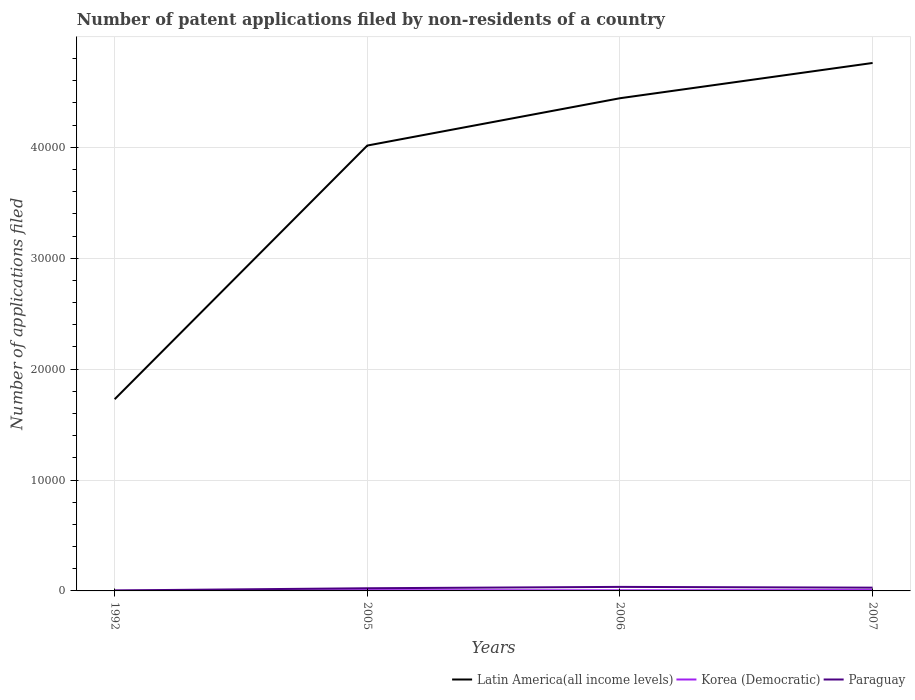Is the number of lines equal to the number of legend labels?
Your answer should be compact. Yes. Across all years, what is the maximum number of applications filed in Latin America(all income levels)?
Your answer should be very brief. 1.73e+04. What is the total number of applications filed in Latin America(all income levels) in the graph?
Give a very brief answer. -7447. What is the difference between the highest and the second highest number of applications filed in Latin America(all income levels)?
Ensure brevity in your answer.  3.03e+04. What is the difference between the highest and the lowest number of applications filed in Paraguay?
Offer a very short reply. 3. Does the graph contain any zero values?
Your answer should be compact. No. How are the legend labels stacked?
Make the answer very short. Horizontal. What is the title of the graph?
Give a very brief answer. Number of patent applications filed by non-residents of a country. Does "Fiji" appear as one of the legend labels in the graph?
Offer a very short reply. No. What is the label or title of the Y-axis?
Offer a terse response. Number of applications filed. What is the Number of applications filed in Latin America(all income levels) in 1992?
Keep it short and to the point. 1.73e+04. What is the Number of applications filed in Latin America(all income levels) in 2005?
Make the answer very short. 4.02e+04. What is the Number of applications filed in Korea (Democratic) in 2005?
Offer a terse response. 66. What is the Number of applications filed of Paraguay in 2005?
Your answer should be compact. 241. What is the Number of applications filed in Latin America(all income levels) in 2006?
Give a very brief answer. 4.44e+04. What is the Number of applications filed of Paraguay in 2006?
Your answer should be compact. 364. What is the Number of applications filed of Latin America(all income levels) in 2007?
Your response must be concise. 4.76e+04. What is the Number of applications filed of Paraguay in 2007?
Offer a terse response. 295. Across all years, what is the maximum Number of applications filed of Latin America(all income levels)?
Your answer should be compact. 4.76e+04. Across all years, what is the maximum Number of applications filed in Korea (Democratic)?
Your response must be concise. 76. Across all years, what is the maximum Number of applications filed of Paraguay?
Make the answer very short. 364. Across all years, what is the minimum Number of applications filed of Latin America(all income levels)?
Your answer should be very brief. 1.73e+04. Across all years, what is the minimum Number of applications filed in Korea (Democratic)?
Keep it short and to the point. 8. What is the total Number of applications filed in Latin America(all income levels) in the graph?
Your response must be concise. 1.49e+05. What is the total Number of applications filed in Korea (Democratic) in the graph?
Your answer should be compact. 206. What is the total Number of applications filed in Paraguay in the graph?
Provide a succinct answer. 944. What is the difference between the Number of applications filed in Latin America(all income levels) in 1992 and that in 2005?
Make the answer very short. -2.29e+04. What is the difference between the Number of applications filed of Korea (Democratic) in 1992 and that in 2005?
Ensure brevity in your answer.  -58. What is the difference between the Number of applications filed in Paraguay in 1992 and that in 2005?
Give a very brief answer. -197. What is the difference between the Number of applications filed of Latin America(all income levels) in 1992 and that in 2006?
Provide a short and direct response. -2.71e+04. What is the difference between the Number of applications filed in Korea (Democratic) in 1992 and that in 2006?
Ensure brevity in your answer.  -48. What is the difference between the Number of applications filed in Paraguay in 1992 and that in 2006?
Give a very brief answer. -320. What is the difference between the Number of applications filed in Latin America(all income levels) in 1992 and that in 2007?
Offer a terse response. -3.03e+04. What is the difference between the Number of applications filed in Korea (Democratic) in 1992 and that in 2007?
Your answer should be compact. -68. What is the difference between the Number of applications filed of Paraguay in 1992 and that in 2007?
Offer a terse response. -251. What is the difference between the Number of applications filed in Latin America(all income levels) in 2005 and that in 2006?
Your response must be concise. -4267. What is the difference between the Number of applications filed in Paraguay in 2005 and that in 2006?
Provide a short and direct response. -123. What is the difference between the Number of applications filed in Latin America(all income levels) in 2005 and that in 2007?
Provide a short and direct response. -7447. What is the difference between the Number of applications filed in Korea (Democratic) in 2005 and that in 2007?
Your response must be concise. -10. What is the difference between the Number of applications filed of Paraguay in 2005 and that in 2007?
Keep it short and to the point. -54. What is the difference between the Number of applications filed of Latin America(all income levels) in 2006 and that in 2007?
Your answer should be compact. -3180. What is the difference between the Number of applications filed in Korea (Democratic) in 2006 and that in 2007?
Offer a very short reply. -20. What is the difference between the Number of applications filed of Latin America(all income levels) in 1992 and the Number of applications filed of Korea (Democratic) in 2005?
Give a very brief answer. 1.72e+04. What is the difference between the Number of applications filed of Latin America(all income levels) in 1992 and the Number of applications filed of Paraguay in 2005?
Ensure brevity in your answer.  1.70e+04. What is the difference between the Number of applications filed of Korea (Democratic) in 1992 and the Number of applications filed of Paraguay in 2005?
Your answer should be compact. -233. What is the difference between the Number of applications filed in Latin America(all income levels) in 1992 and the Number of applications filed in Korea (Democratic) in 2006?
Make the answer very short. 1.72e+04. What is the difference between the Number of applications filed of Latin America(all income levels) in 1992 and the Number of applications filed of Paraguay in 2006?
Give a very brief answer. 1.69e+04. What is the difference between the Number of applications filed of Korea (Democratic) in 1992 and the Number of applications filed of Paraguay in 2006?
Ensure brevity in your answer.  -356. What is the difference between the Number of applications filed in Latin America(all income levels) in 1992 and the Number of applications filed in Korea (Democratic) in 2007?
Ensure brevity in your answer.  1.72e+04. What is the difference between the Number of applications filed in Latin America(all income levels) in 1992 and the Number of applications filed in Paraguay in 2007?
Provide a succinct answer. 1.70e+04. What is the difference between the Number of applications filed of Korea (Democratic) in 1992 and the Number of applications filed of Paraguay in 2007?
Give a very brief answer. -287. What is the difference between the Number of applications filed of Latin America(all income levels) in 2005 and the Number of applications filed of Korea (Democratic) in 2006?
Your answer should be compact. 4.01e+04. What is the difference between the Number of applications filed of Latin America(all income levels) in 2005 and the Number of applications filed of Paraguay in 2006?
Provide a succinct answer. 3.98e+04. What is the difference between the Number of applications filed of Korea (Democratic) in 2005 and the Number of applications filed of Paraguay in 2006?
Your answer should be very brief. -298. What is the difference between the Number of applications filed in Latin America(all income levels) in 2005 and the Number of applications filed in Korea (Democratic) in 2007?
Provide a short and direct response. 4.01e+04. What is the difference between the Number of applications filed of Latin America(all income levels) in 2005 and the Number of applications filed of Paraguay in 2007?
Your answer should be compact. 3.99e+04. What is the difference between the Number of applications filed of Korea (Democratic) in 2005 and the Number of applications filed of Paraguay in 2007?
Provide a short and direct response. -229. What is the difference between the Number of applications filed of Latin America(all income levels) in 2006 and the Number of applications filed of Korea (Democratic) in 2007?
Your answer should be very brief. 4.44e+04. What is the difference between the Number of applications filed of Latin America(all income levels) in 2006 and the Number of applications filed of Paraguay in 2007?
Keep it short and to the point. 4.41e+04. What is the difference between the Number of applications filed of Korea (Democratic) in 2006 and the Number of applications filed of Paraguay in 2007?
Offer a very short reply. -239. What is the average Number of applications filed in Latin America(all income levels) per year?
Provide a short and direct response. 3.74e+04. What is the average Number of applications filed of Korea (Democratic) per year?
Offer a very short reply. 51.5. What is the average Number of applications filed of Paraguay per year?
Provide a succinct answer. 236. In the year 1992, what is the difference between the Number of applications filed in Latin America(all income levels) and Number of applications filed in Korea (Democratic)?
Make the answer very short. 1.73e+04. In the year 1992, what is the difference between the Number of applications filed in Latin America(all income levels) and Number of applications filed in Paraguay?
Your answer should be very brief. 1.72e+04. In the year 1992, what is the difference between the Number of applications filed of Korea (Democratic) and Number of applications filed of Paraguay?
Ensure brevity in your answer.  -36. In the year 2005, what is the difference between the Number of applications filed in Latin America(all income levels) and Number of applications filed in Korea (Democratic)?
Offer a very short reply. 4.01e+04. In the year 2005, what is the difference between the Number of applications filed of Latin America(all income levels) and Number of applications filed of Paraguay?
Offer a terse response. 3.99e+04. In the year 2005, what is the difference between the Number of applications filed of Korea (Democratic) and Number of applications filed of Paraguay?
Make the answer very short. -175. In the year 2006, what is the difference between the Number of applications filed in Latin America(all income levels) and Number of applications filed in Korea (Democratic)?
Your answer should be compact. 4.44e+04. In the year 2006, what is the difference between the Number of applications filed in Latin America(all income levels) and Number of applications filed in Paraguay?
Offer a very short reply. 4.41e+04. In the year 2006, what is the difference between the Number of applications filed in Korea (Democratic) and Number of applications filed in Paraguay?
Keep it short and to the point. -308. In the year 2007, what is the difference between the Number of applications filed in Latin America(all income levels) and Number of applications filed in Korea (Democratic)?
Provide a short and direct response. 4.75e+04. In the year 2007, what is the difference between the Number of applications filed in Latin America(all income levels) and Number of applications filed in Paraguay?
Your answer should be very brief. 4.73e+04. In the year 2007, what is the difference between the Number of applications filed of Korea (Democratic) and Number of applications filed of Paraguay?
Offer a terse response. -219. What is the ratio of the Number of applications filed of Latin America(all income levels) in 1992 to that in 2005?
Provide a succinct answer. 0.43. What is the ratio of the Number of applications filed in Korea (Democratic) in 1992 to that in 2005?
Your answer should be compact. 0.12. What is the ratio of the Number of applications filed of Paraguay in 1992 to that in 2005?
Your answer should be very brief. 0.18. What is the ratio of the Number of applications filed in Latin America(all income levels) in 1992 to that in 2006?
Your answer should be very brief. 0.39. What is the ratio of the Number of applications filed in Korea (Democratic) in 1992 to that in 2006?
Offer a terse response. 0.14. What is the ratio of the Number of applications filed in Paraguay in 1992 to that in 2006?
Offer a terse response. 0.12. What is the ratio of the Number of applications filed in Latin America(all income levels) in 1992 to that in 2007?
Give a very brief answer. 0.36. What is the ratio of the Number of applications filed in Korea (Democratic) in 1992 to that in 2007?
Your response must be concise. 0.11. What is the ratio of the Number of applications filed in Paraguay in 1992 to that in 2007?
Keep it short and to the point. 0.15. What is the ratio of the Number of applications filed in Latin America(all income levels) in 2005 to that in 2006?
Offer a terse response. 0.9. What is the ratio of the Number of applications filed of Korea (Democratic) in 2005 to that in 2006?
Your response must be concise. 1.18. What is the ratio of the Number of applications filed of Paraguay in 2005 to that in 2006?
Give a very brief answer. 0.66. What is the ratio of the Number of applications filed in Latin America(all income levels) in 2005 to that in 2007?
Make the answer very short. 0.84. What is the ratio of the Number of applications filed of Korea (Democratic) in 2005 to that in 2007?
Your answer should be very brief. 0.87. What is the ratio of the Number of applications filed in Paraguay in 2005 to that in 2007?
Offer a very short reply. 0.82. What is the ratio of the Number of applications filed in Latin America(all income levels) in 2006 to that in 2007?
Your answer should be compact. 0.93. What is the ratio of the Number of applications filed of Korea (Democratic) in 2006 to that in 2007?
Ensure brevity in your answer.  0.74. What is the ratio of the Number of applications filed in Paraguay in 2006 to that in 2007?
Your response must be concise. 1.23. What is the difference between the highest and the second highest Number of applications filed in Latin America(all income levels)?
Your response must be concise. 3180. What is the difference between the highest and the lowest Number of applications filed of Latin America(all income levels)?
Keep it short and to the point. 3.03e+04. What is the difference between the highest and the lowest Number of applications filed in Paraguay?
Keep it short and to the point. 320. 